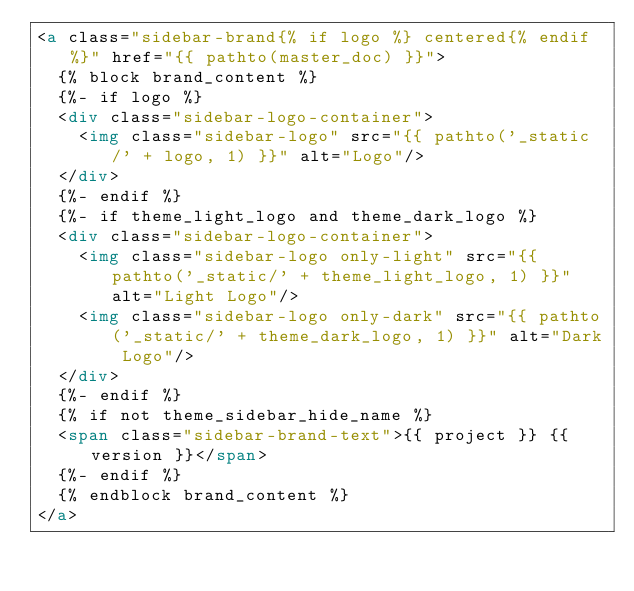<code> <loc_0><loc_0><loc_500><loc_500><_HTML_><a class="sidebar-brand{% if logo %} centered{% endif %}" href="{{ pathto(master_doc) }}">
  {% block brand_content %}
  {%- if logo %}
  <div class="sidebar-logo-container">
    <img class="sidebar-logo" src="{{ pathto('_static/' + logo, 1) }}" alt="Logo"/>
  </div>
  {%- endif %}
  {%- if theme_light_logo and theme_dark_logo %}
  <div class="sidebar-logo-container">
    <img class="sidebar-logo only-light" src="{{ pathto('_static/' + theme_light_logo, 1) }}" alt="Light Logo"/>
    <img class="sidebar-logo only-dark" src="{{ pathto('_static/' + theme_dark_logo, 1) }}" alt="Dark Logo"/>
  </div>
  {%- endif %}
  {% if not theme_sidebar_hide_name %}
  <span class="sidebar-brand-text">{{ project }} {{ version }}</span>
  {%- endif %}
  {% endblock brand_content %}
</a>
</code> 